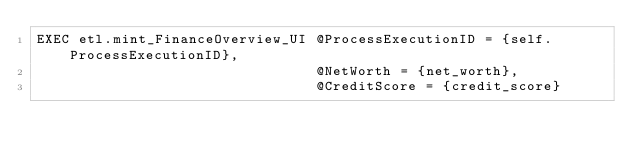Convert code to text. <code><loc_0><loc_0><loc_500><loc_500><_SQL_>EXEC etl.mint_FinanceOverview_UI @ProcessExecutionID = {self.ProcessExecutionID},
                                 @NetWorth = {net_worth},
                                 @CreditScore = {credit_score}
</code> 